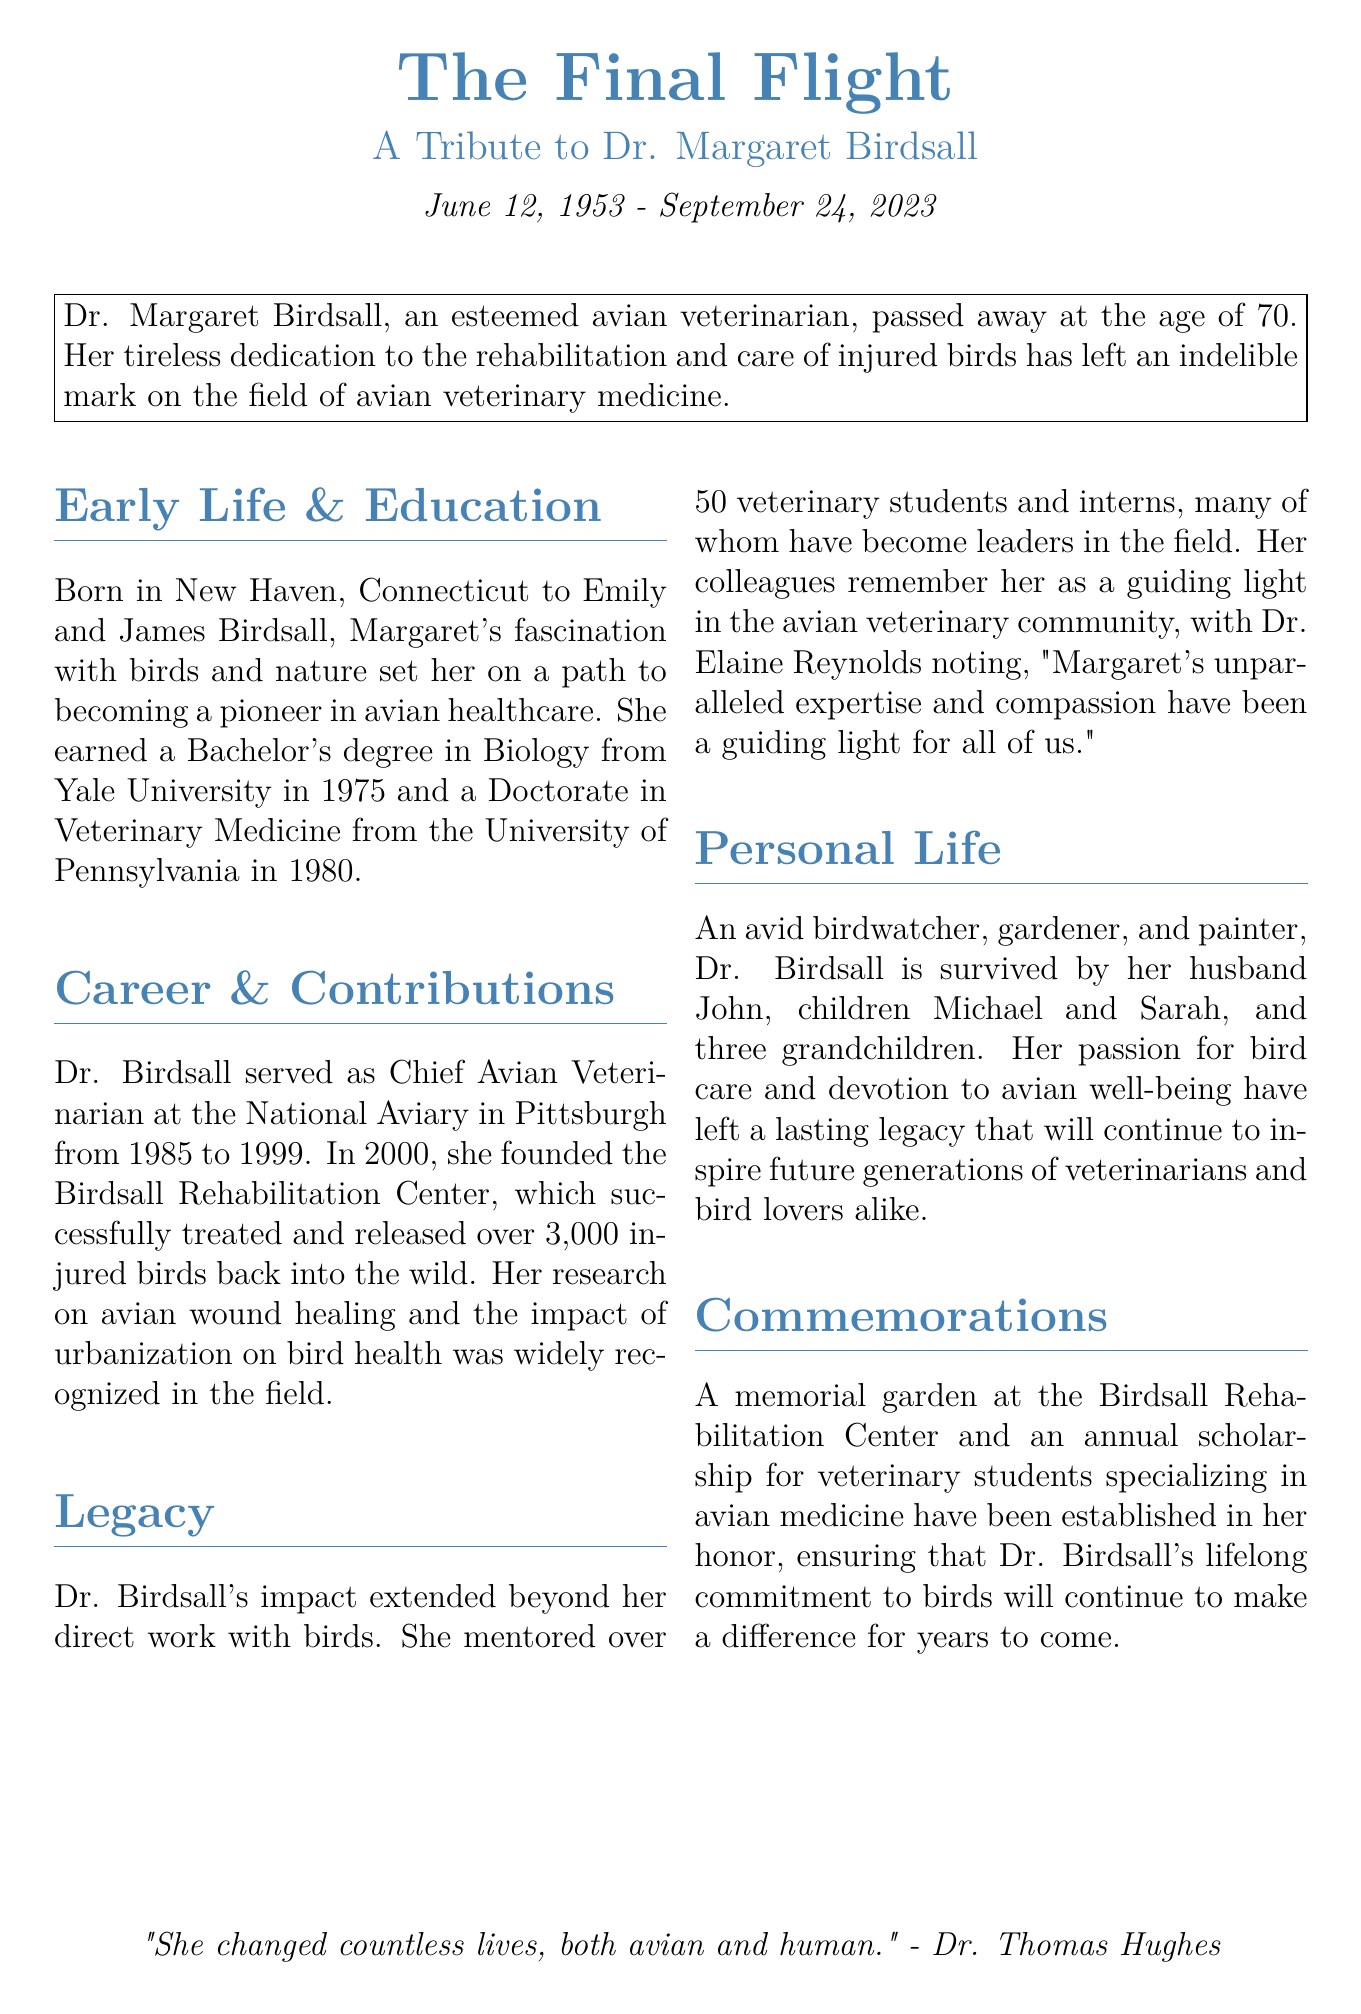What is Dr. Birdsall's full name? Dr. Birdsall's full name is mentioned at the beginning of the tribute.
Answer: Dr. Margaret Birdsall What year did Dr. Birdsall pass away? The document states the date of her passing directly.
Answer: 2023 What institution did Dr. Birdsall receive her Doctorate in Veterinary Medicine from? The document specifies the university where she earned her doctorate.
Answer: University of Pennsylvania How many injured birds did the Birdsall Rehabilitation Center treat? The center's success in bird treatment is quantified in the document.
Answer: 3,000 What is established in Dr. Birdsall's honor at the Birdsall Rehabilitation Center? The document outlines commemorative initiatives set up in her name.
Answer: A memorial garden Who noted Dr. Birdsall as a guiding light in the avian veterinary community? The document quotes a colleague who recognized her expertise and compassion.
Answer: Dr. Elaine Reynolds What degree did Dr. Birdsall earn from Yale University? The document explicitly mentions her educational qualification from Yale.
Answer: Bachelor's degree in Biology What was Dr. Birdsall's age at the time of her passing? The document indicates her age when she passed away.
Answer: 70 